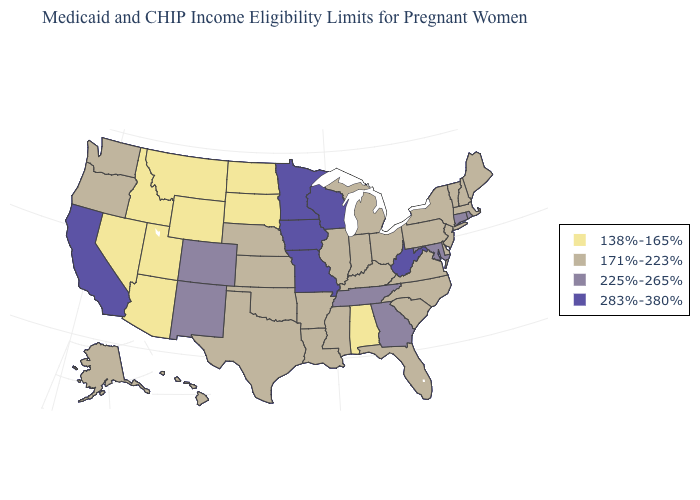What is the value of New York?
Give a very brief answer. 171%-223%. What is the value of Iowa?
Keep it brief. 283%-380%. Name the states that have a value in the range 283%-380%?
Concise answer only. California, Iowa, Minnesota, Missouri, West Virginia, Wisconsin. What is the lowest value in the Northeast?
Short answer required. 171%-223%. What is the value of Oklahoma?
Keep it brief. 171%-223%. What is the value of New York?
Give a very brief answer. 171%-223%. What is the highest value in the MidWest ?
Be succinct. 283%-380%. Name the states that have a value in the range 283%-380%?
Short answer required. California, Iowa, Minnesota, Missouri, West Virginia, Wisconsin. What is the value of Rhode Island?
Be succinct. 225%-265%. Which states have the lowest value in the USA?
Answer briefly. Alabama, Arizona, Idaho, Montana, Nevada, North Dakota, South Dakota, Utah, Wyoming. How many symbols are there in the legend?
Short answer required. 4. Among the states that border Michigan , does Wisconsin have the highest value?
Give a very brief answer. Yes. Name the states that have a value in the range 171%-223%?
Quick response, please. Alaska, Arkansas, Delaware, Florida, Hawaii, Illinois, Indiana, Kansas, Kentucky, Louisiana, Maine, Massachusetts, Michigan, Mississippi, Nebraska, New Hampshire, New Jersey, New York, North Carolina, Ohio, Oklahoma, Oregon, Pennsylvania, South Carolina, Texas, Vermont, Virginia, Washington. What is the value of Louisiana?
Write a very short answer. 171%-223%. Among the states that border Alabama , does Georgia have the lowest value?
Give a very brief answer. No. 